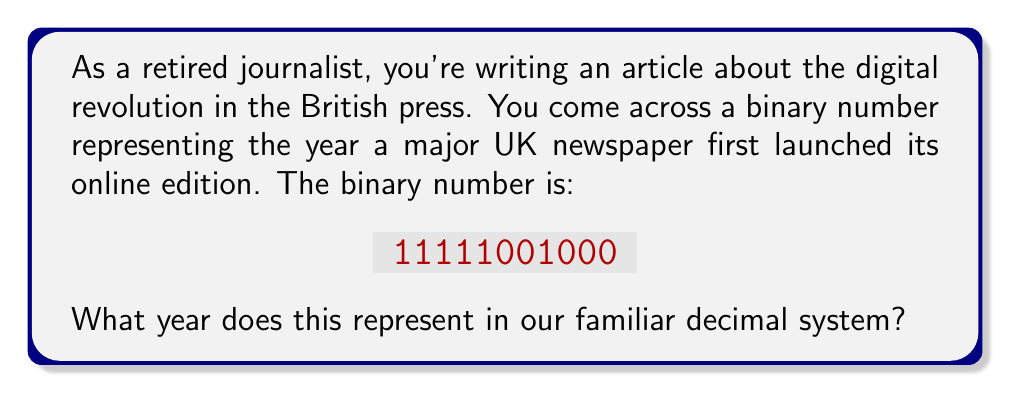Help me with this question. To convert a binary number to decimal, we need to multiply each digit by a power of 2 and sum the results. The rightmost digit represents $2^0$, the next $2^1$, then $2^2$, and so on.

Let's break it down step-by-step:

1) First, let's write out the binary number with its corresponding powers of 2:

   $$11111001000_2 = (1\times2^{10}) + (1\times2^9) + (1\times2^8) + (1\times2^7) + (1\times2^6) + (1\times2^5) + (0\times2^4) + (0\times2^3) + (1\times2^2) + (0\times2^1) + (0\times2^0)$$

2) Now, let's calculate each term:

   $$1024 + 512 + 256 + 128 + 64 + 32 + 0 + 0 + 4 + 0 + 0$$

3) Sum up all these values:

   $$1024 + 512 + 256 + 128 + 64 + 32 + 4 = 2020$$

Therefore, the binary number 11111001000 represents the decimal number 2020.
Answer: 2020 